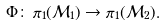<formula> <loc_0><loc_0><loc_500><loc_500>\Phi \colon \, \pi _ { 1 } ( \mathcal { M } _ { 1 } ) \to \pi _ { 1 } ( \mathcal { M } _ { 2 } ) .</formula> 